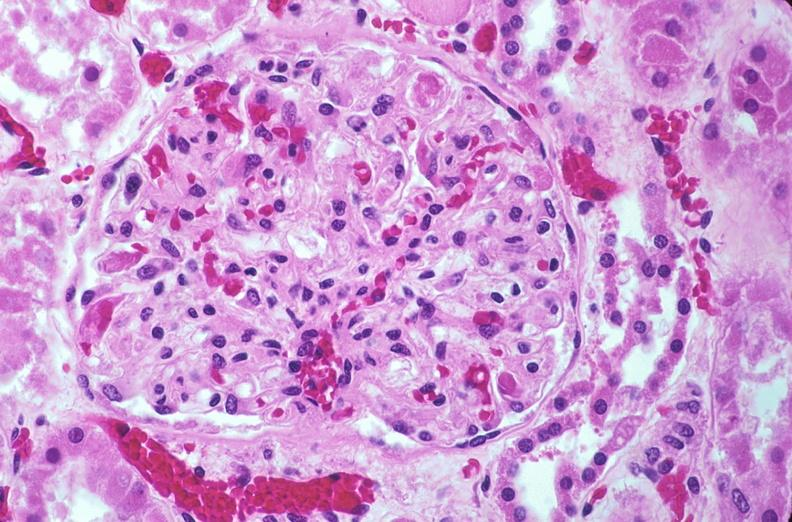where is this?
Answer the question using a single word or phrase. Urinary 